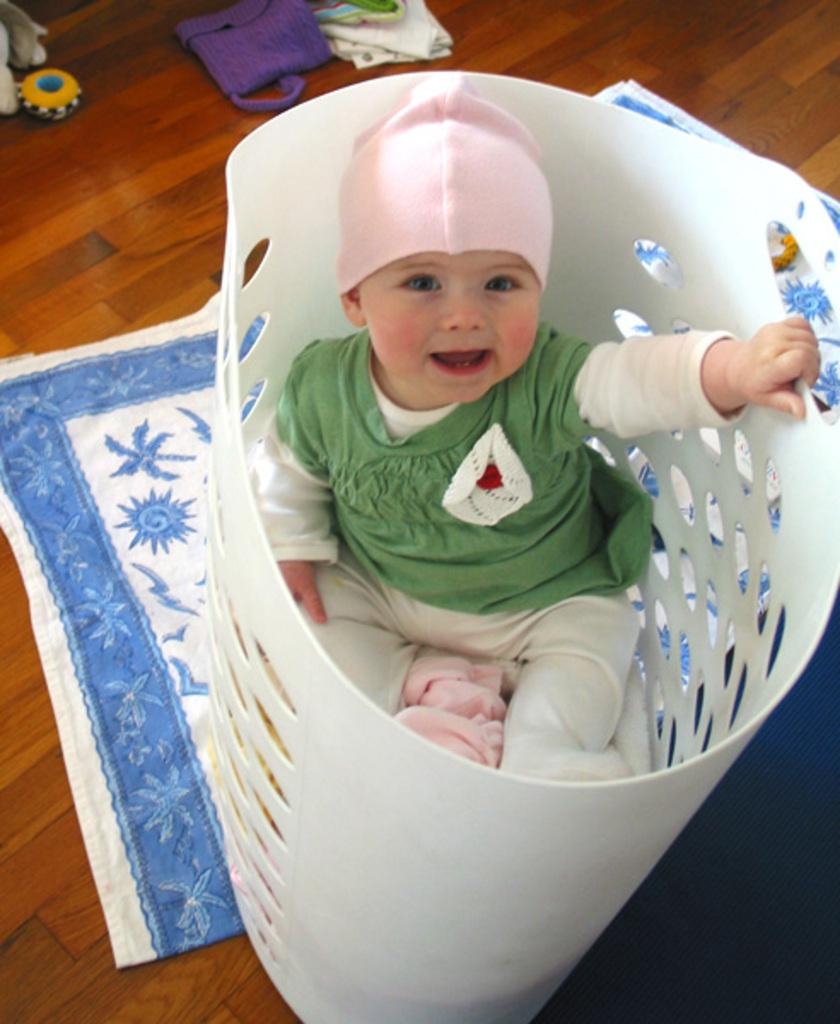What is the kid doing in the image? The kid is in a basket in the image. Where is the basket located? The basket is on the floor. What else can be seen in the image besides the kid and the basket? There are clothes visible in the image. How many chickens are in the basket with the kid? There are no chickens present in the image; it only shows a kid in a basket on the floor. 